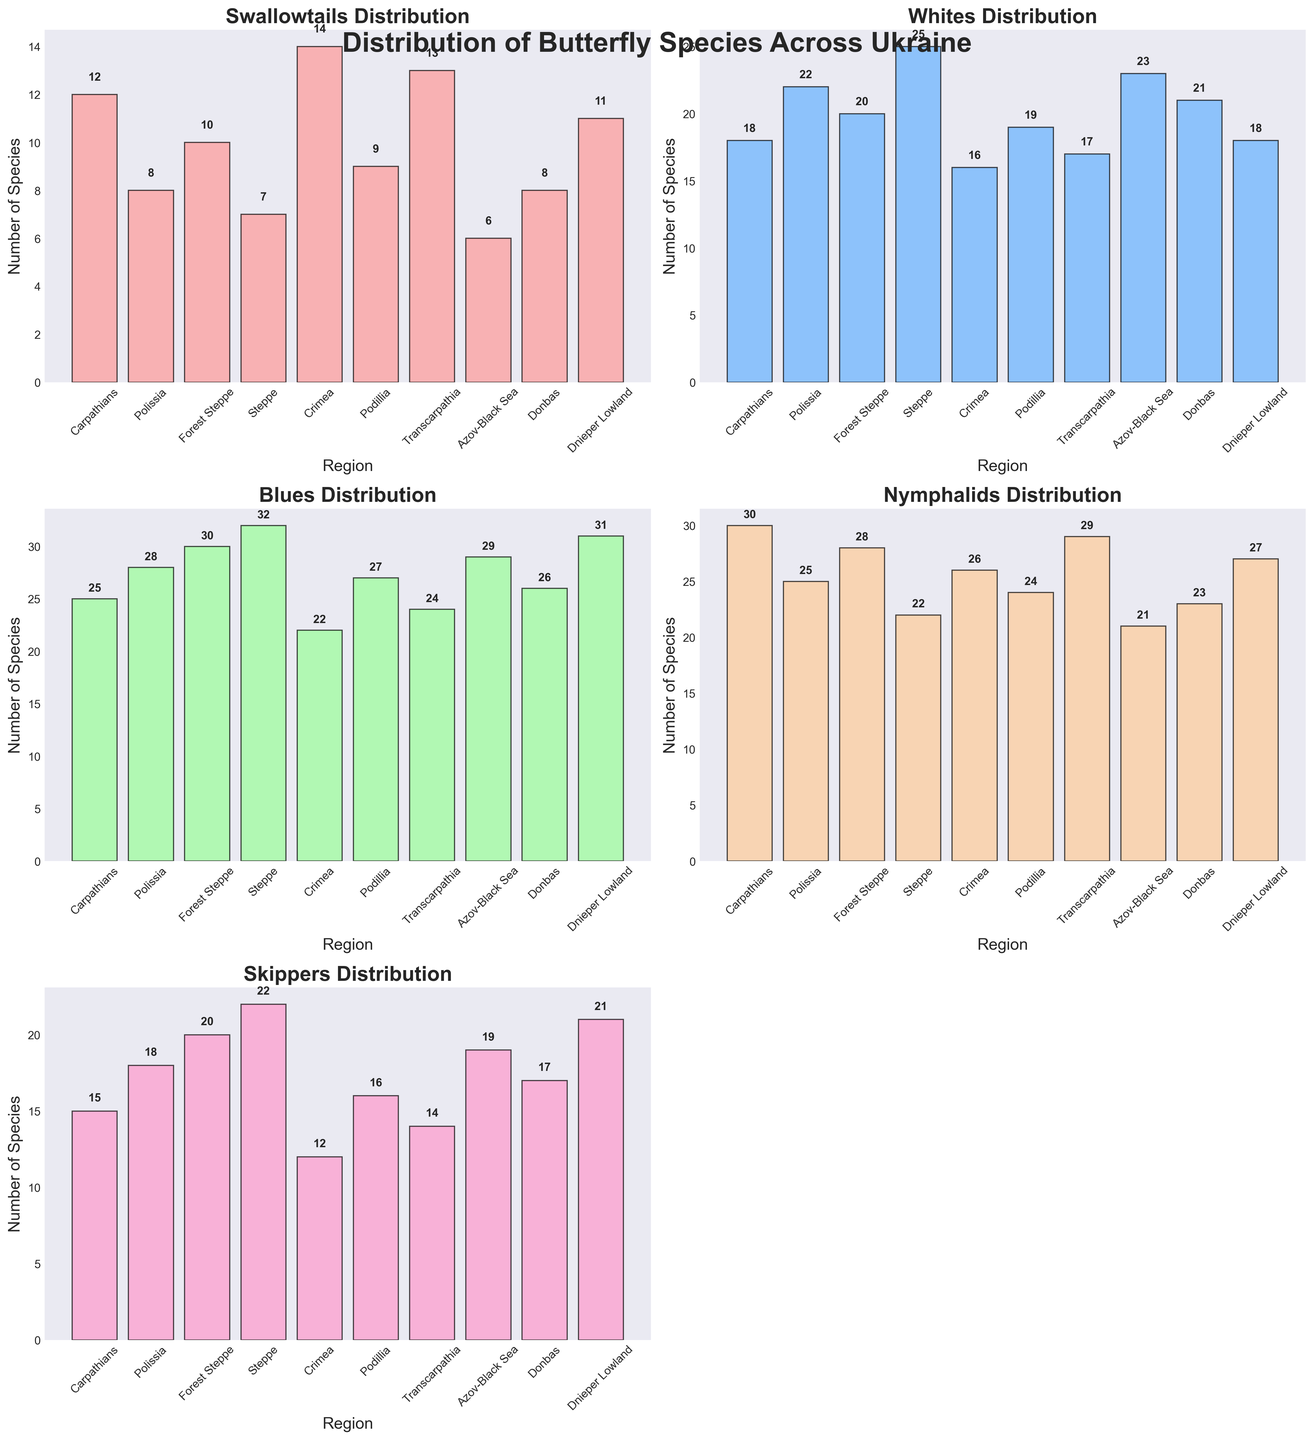Which region has the highest number of Blue butterflies? To determine this, look at the subplot for Blues. The region with the tallest bar and the highest value label is Steppe.
Answer: Steppe What is the total number of Skippers across all regions? Sum the values for Skippers from all regions. These values are 15 (Carpathians) + 18 (Polissia) + 20 (Forest Steppe) + 22 (Steppe) + 12 (Crimea) + 16 (Podillia) + 14 (Transcarpathia) + 19 (Azov-Black Sea) + 17 (Donbas) + 21 (Dnieper Lowland). The total is 174.
Answer: 174 How many more Whites are there than Swallowtails in Polissia? To find this, subtract the number of Swallowtails from the number of Whites in Polissia: 22 (Whites) - 8 (Swallowtails) = 14.
Answer: 14 Which region has the lowest number of Swallowtails? Check the subplot for Swallowtails. The region with the shortest bar is Azov-Black Sea with 6 Swallowtails.
Answer: Azov-Black Sea In which region(s) are the numbers of Blues and Nymphalids almost equal? Compare the values of Blues and Nymphalids in each region. Regions where these values are close are Carpathians (Blues: 25, Nymphalids: 30) and Crimea (Blues: 22, Nymphalids: 26). Although not exact, the differences are relatively small compared to other regions.
Answer: Carpathians, Crimea What is the average number of Nymphalids across all regions? To calculate this, sum the numbers of Nymphalids and divide by the number of regions. Sum: 30 (Carpathians) + 25 (Polissia) + 28 (Forest Steppe) + 22 (Steppe) + 26 (Crimea) + 24 (Podillia) + 29 (Transcarpathia) + 21 (Azov-Black Sea) + 23 (Donbas) + 27 (Dnieper Lowland) = 255. Number of regions: 10. Average: 255 / 10 = 25.5.
Answer: 25.5 Which butterfly type has the least variation across regions? Visually inspect the subplots for the ranges in bar heights. Whites appear to have the least variation since their values are relatively more consistent compared to other types.
Answer: Whites How does the number of Swallowtails in Dnieper Lowland compare to other regions? Dnieper Lowland has 11 Swallowtails; visually, this number is not the highest (such as 14 in Crimea) nor the lowest (such as 6 in Azov-Black Sea). It falls somewhere in the middle range.
Answer: Middle range 